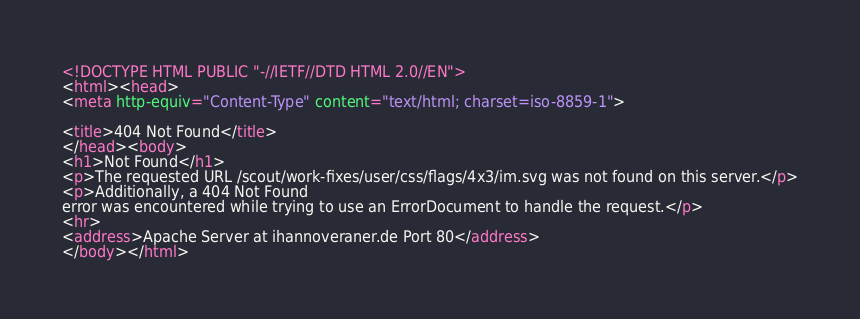Convert code to text. <code><loc_0><loc_0><loc_500><loc_500><_HTML_><!DOCTYPE HTML PUBLIC "-//IETF//DTD HTML 2.0//EN">
<html><head>
<meta http-equiv="Content-Type" content="text/html; charset=iso-8859-1">

<title>404 Not Found</title>
</head><body>
<h1>Not Found</h1>
<p>The requested URL /scout/work-fixes/user/css/flags/4x3/im.svg was not found on this server.</p>
<p>Additionally, a 404 Not Found
error was encountered while trying to use an ErrorDocument to handle the request.</p>
<hr>
<address>Apache Server at ihannoveraner.de Port 80</address>
</body></html>
</code> 